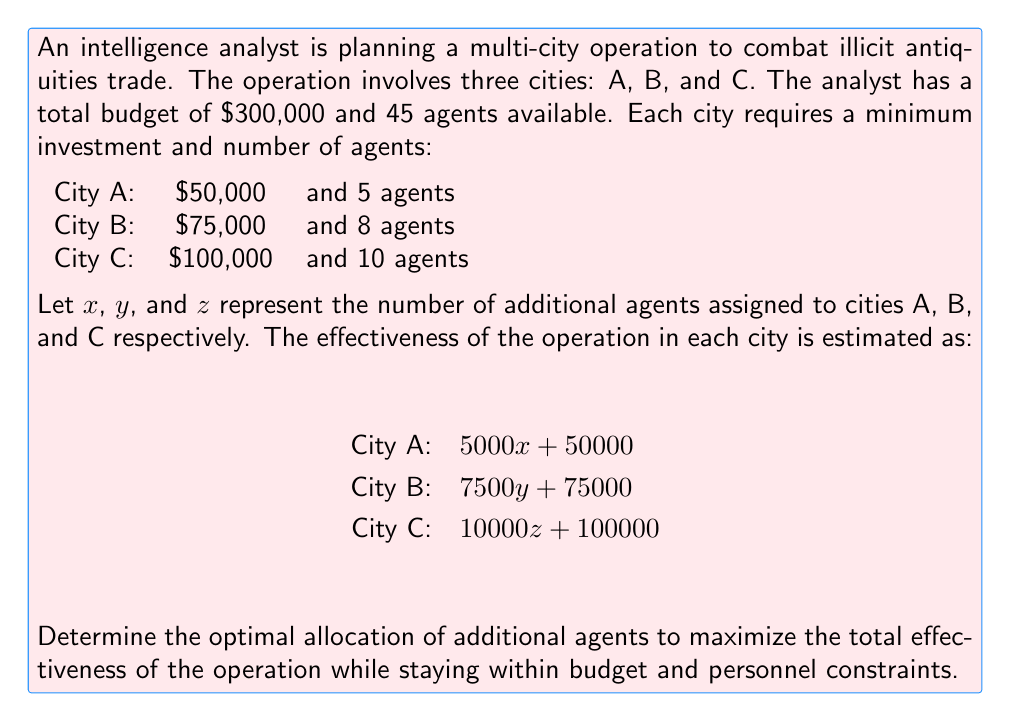Show me your answer to this math problem. To solve this problem, we'll use linear programming:

1. Define the objective function:
   Maximize $f(x,y,z) = (5000x + 50000) + (7500y + 75000) + (10000z + 100000)$

2. Set up constraints:
   a) Budget constraint: $(50000 + 5000x) + (75000 + 7500y) + (100000 + 10000z) \leq 300000$
   b) Personnel constraint: $(5 + x) + (8 + y) + (10 + z) \leq 45$
   c) Non-negativity: $x \geq 0$, $y \geq 0$, $z \geq 0$

3. Simplify the constraints:
   a) $5000x + 7500y + 10000z \leq 75000$
   b) $x + y + z \leq 22$

4. Solve using the corner point method:
   Potential corner points: (0,0,0), (22,0,0), (0,22,0), (0,0,22), (15,0,7), (0,10,12), (7,15,0)

5. Evaluate the objective function at each point:
   f(0,0,0) = 225000
   f(22,0,0) = 335000
   f(0,22,0) = 390000
   f(0,0,22) = 545000 (exceeds budget constraint)
   f(15,0,7) = 395000
   f(0,10,12) = 445000
   f(7,15,0) = 397500

6. The maximum value that satisfies all constraints is at (0,10,12).

Therefore, the optimal allocation is:
City A: 5 agents (minimum)
City B: 18 agents (8 minimum + 10 additional)
City C: 22 agents (10 minimum + 12 additional)
Answer: City A: 5 agents, City B: 18 agents, City C: 22 agents 